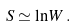<formula> <loc_0><loc_0><loc_500><loc_500>S \simeq \ln W \, .</formula> 